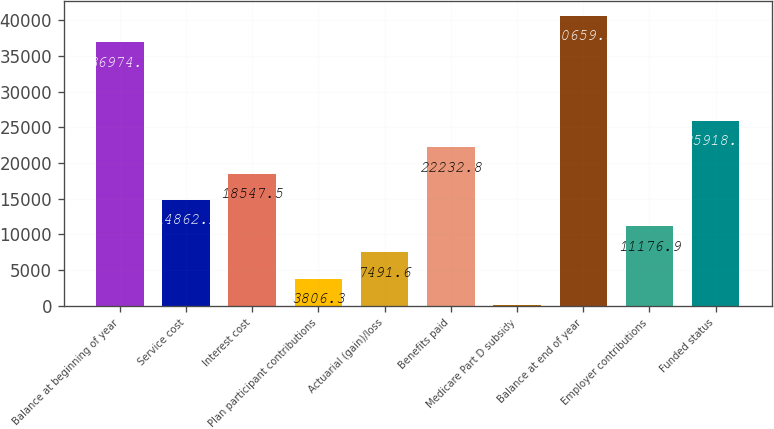Convert chart. <chart><loc_0><loc_0><loc_500><loc_500><bar_chart><fcel>Balance at beginning of year<fcel>Service cost<fcel>Interest cost<fcel>Plan participant contributions<fcel>Actuarial (gain)/loss<fcel>Benefits paid<fcel>Medicare Part D subsidy<fcel>Balance at end of year<fcel>Employer contributions<fcel>Funded status<nl><fcel>36974<fcel>14862.2<fcel>18547.5<fcel>3806.3<fcel>7491.6<fcel>22232.8<fcel>121<fcel>40659.3<fcel>11176.9<fcel>25918.1<nl></chart> 